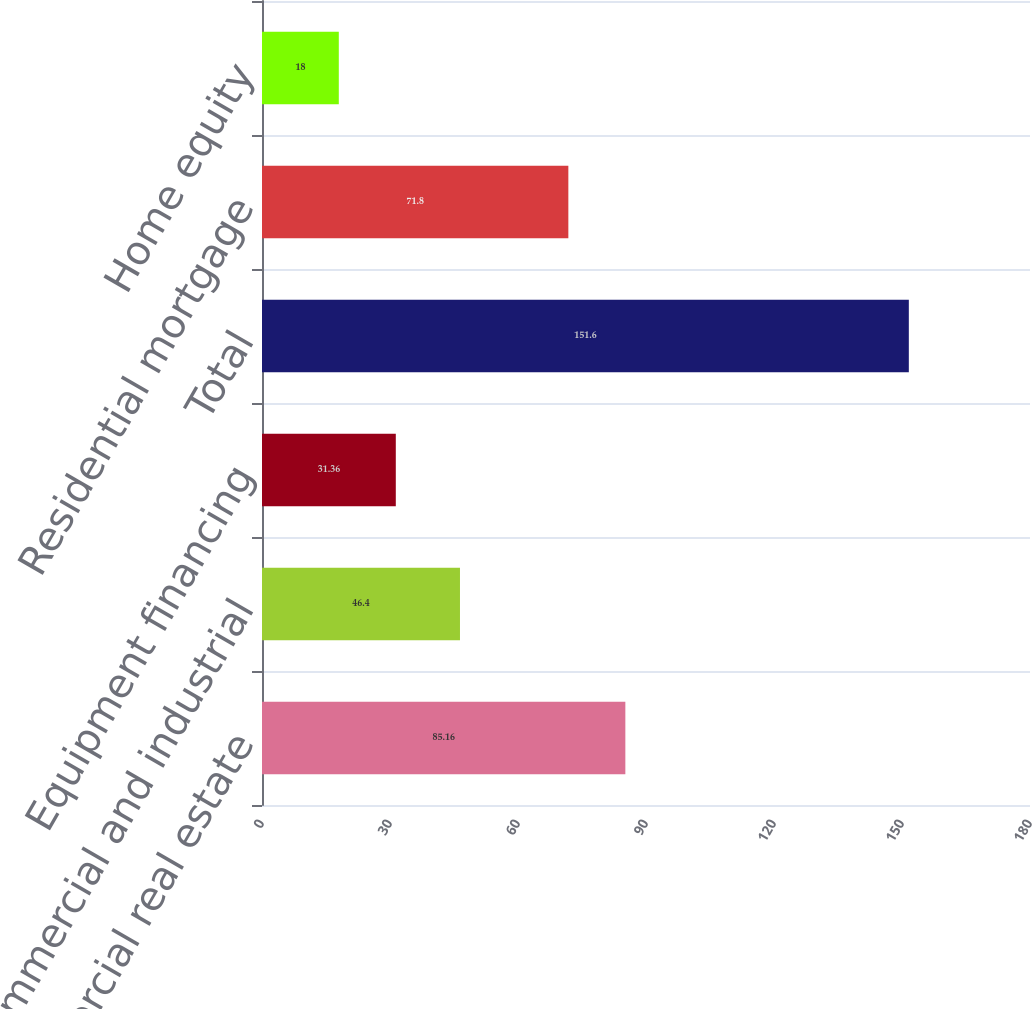Convert chart. <chart><loc_0><loc_0><loc_500><loc_500><bar_chart><fcel>Commercial real estate<fcel>Commercial and industrial<fcel>Equipment financing<fcel>Total<fcel>Residential mortgage<fcel>Home equity<nl><fcel>85.16<fcel>46.4<fcel>31.36<fcel>151.6<fcel>71.8<fcel>18<nl></chart> 